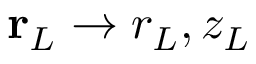Convert formula to latex. <formula><loc_0><loc_0><loc_500><loc_500>r _ { L } \rightarrow r _ { L } , z _ { L }</formula> 